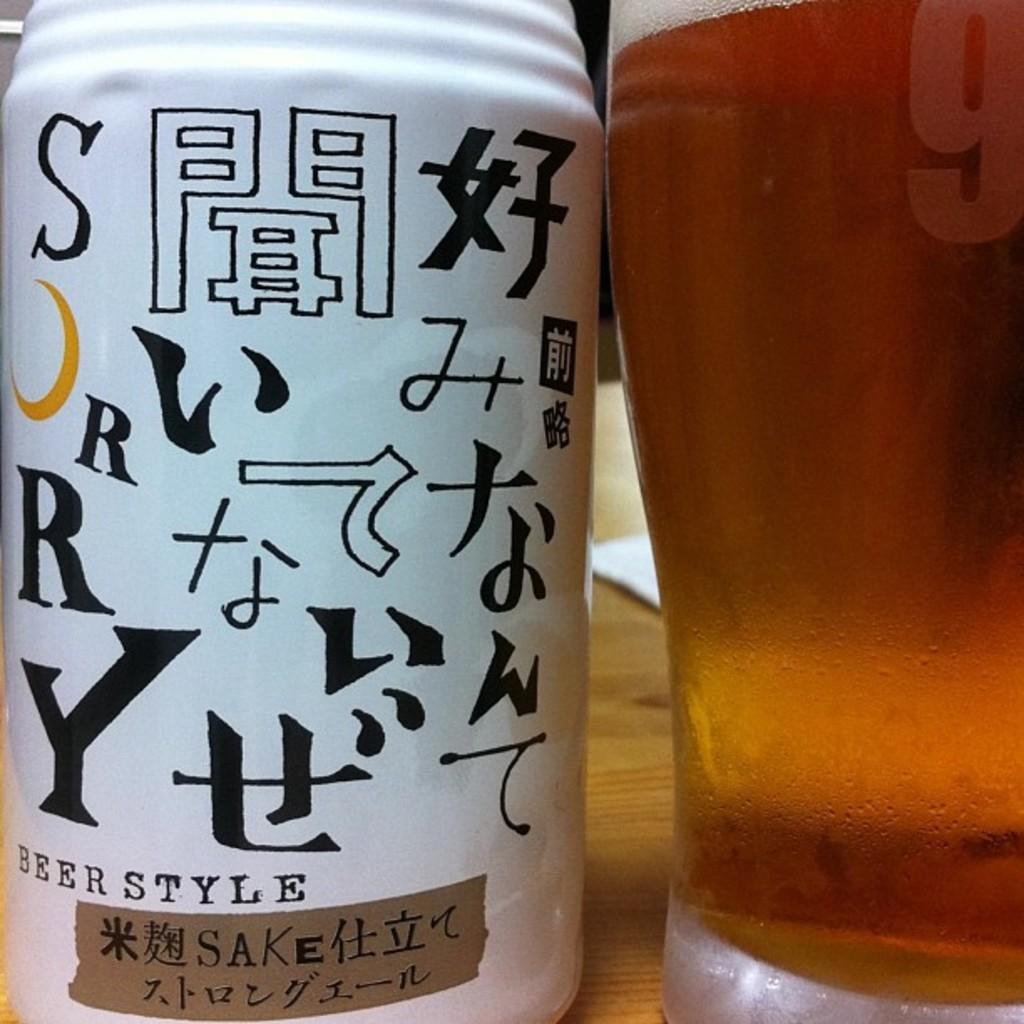<image>
Give a short and clear explanation of the subsequent image. a bottle that is all white and is labeled 'beer style sake' 